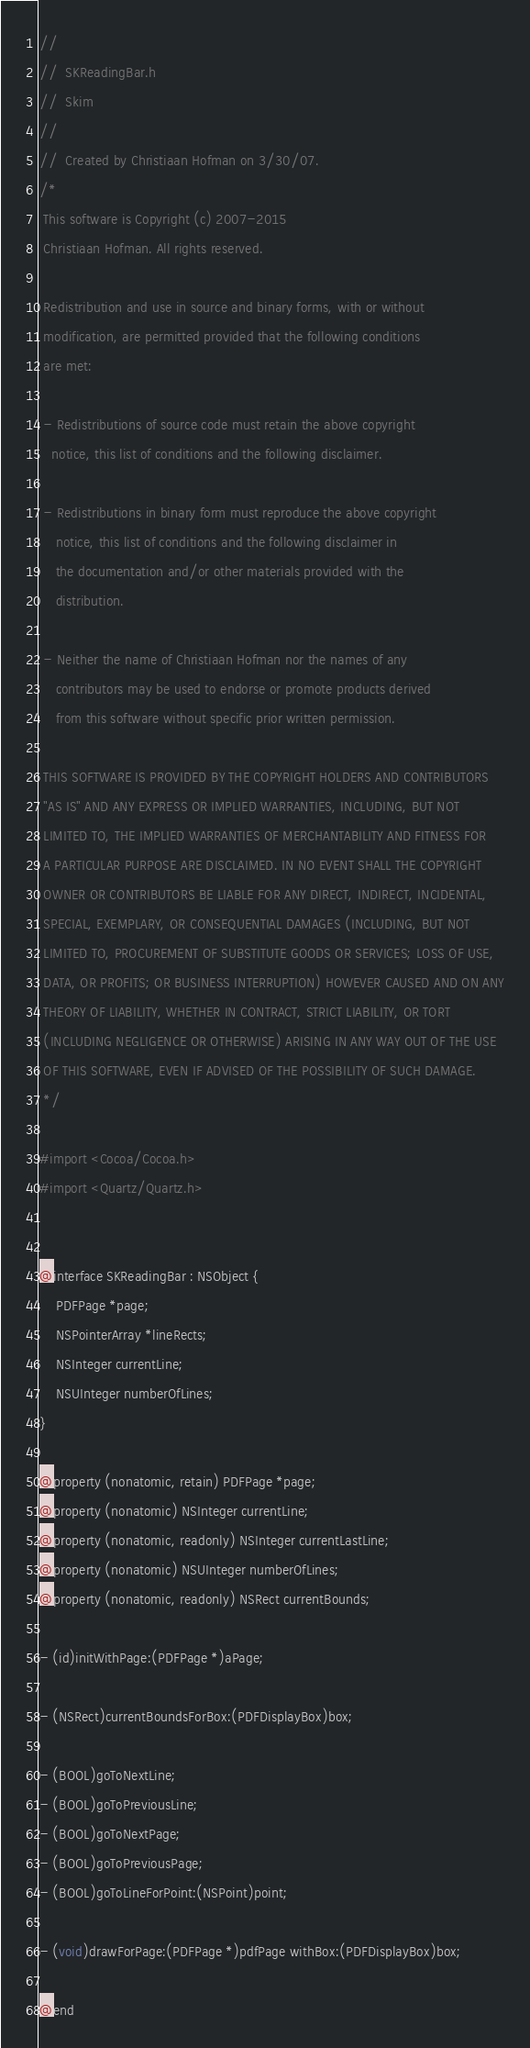<code> <loc_0><loc_0><loc_500><loc_500><_C_>//
//  SKReadingBar.h
//  Skim
//
//  Created by Christiaan Hofman on 3/30/07.
/*
 This software is Copyright (c) 2007-2015
 Christiaan Hofman. All rights reserved.

 Redistribution and use in source and binary forms, with or without
 modification, are permitted provided that the following conditions
 are met:

 - Redistributions of source code must retain the above copyright
   notice, this list of conditions and the following disclaimer.

 - Redistributions in binary form must reproduce the above copyright
    notice, this list of conditions and the following disclaimer in
    the documentation and/or other materials provided with the
    distribution.

 - Neither the name of Christiaan Hofman nor the names of any
    contributors may be used to endorse or promote products derived
    from this software without specific prior written permission.

 THIS SOFTWARE IS PROVIDED BY THE COPYRIGHT HOLDERS AND CONTRIBUTORS
 "AS IS" AND ANY EXPRESS OR IMPLIED WARRANTIES, INCLUDING, BUT NOT
 LIMITED TO, THE IMPLIED WARRANTIES OF MERCHANTABILITY AND FITNESS FOR
 A PARTICULAR PURPOSE ARE DISCLAIMED. IN NO EVENT SHALL THE COPYRIGHT
 OWNER OR CONTRIBUTORS BE LIABLE FOR ANY DIRECT, INDIRECT, INCIDENTAL,
 SPECIAL, EXEMPLARY, OR CONSEQUENTIAL DAMAGES (INCLUDING, BUT NOT
 LIMITED TO, PROCUREMENT OF SUBSTITUTE GOODS OR SERVICES; LOSS OF USE,
 DATA, OR PROFITS; OR BUSINESS INTERRUPTION) HOWEVER CAUSED AND ON ANY
 THEORY OF LIABILITY, WHETHER IN CONTRACT, STRICT LIABILITY, OR TORT
 (INCLUDING NEGLIGENCE OR OTHERWISE) ARISING IN ANY WAY OUT OF THE USE
 OF THIS SOFTWARE, EVEN IF ADVISED OF THE POSSIBILITY OF SUCH DAMAGE.
 */

#import <Cocoa/Cocoa.h>
#import <Quartz/Quartz.h>


@interface SKReadingBar : NSObject {
    PDFPage *page;
    NSPointerArray *lineRects;
    NSInteger currentLine;
    NSUInteger numberOfLines;
}

@property (nonatomic, retain) PDFPage *page;
@property (nonatomic) NSInteger currentLine;
@property (nonatomic, readonly) NSInteger currentLastLine;
@property (nonatomic) NSUInteger numberOfLines;
@property (nonatomic, readonly) NSRect currentBounds;

- (id)initWithPage:(PDFPage *)aPage;

- (NSRect)currentBoundsForBox:(PDFDisplayBox)box;

- (BOOL)goToNextLine;
- (BOOL)goToPreviousLine;
- (BOOL)goToNextPage;
- (BOOL)goToPreviousPage;
- (BOOL)goToLineForPoint:(NSPoint)point;

- (void)drawForPage:(PDFPage *)pdfPage withBox:(PDFDisplayBox)box;

@end
</code> 